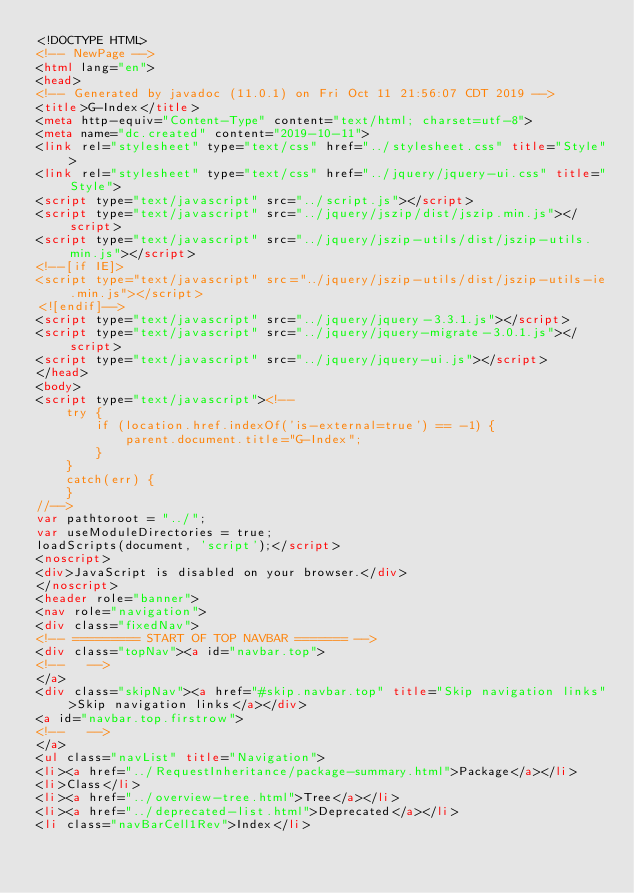<code> <loc_0><loc_0><loc_500><loc_500><_HTML_><!DOCTYPE HTML>
<!-- NewPage -->
<html lang="en">
<head>
<!-- Generated by javadoc (11.0.1) on Fri Oct 11 21:56:07 CDT 2019 -->
<title>G-Index</title>
<meta http-equiv="Content-Type" content="text/html; charset=utf-8">
<meta name="dc.created" content="2019-10-11">
<link rel="stylesheet" type="text/css" href="../stylesheet.css" title="Style">
<link rel="stylesheet" type="text/css" href="../jquery/jquery-ui.css" title="Style">
<script type="text/javascript" src="../script.js"></script>
<script type="text/javascript" src="../jquery/jszip/dist/jszip.min.js"></script>
<script type="text/javascript" src="../jquery/jszip-utils/dist/jszip-utils.min.js"></script>
<!--[if IE]>
<script type="text/javascript" src="../jquery/jszip-utils/dist/jszip-utils-ie.min.js"></script>
<![endif]-->
<script type="text/javascript" src="../jquery/jquery-3.3.1.js"></script>
<script type="text/javascript" src="../jquery/jquery-migrate-3.0.1.js"></script>
<script type="text/javascript" src="../jquery/jquery-ui.js"></script>
</head>
<body>
<script type="text/javascript"><!--
    try {
        if (location.href.indexOf('is-external=true') == -1) {
            parent.document.title="G-Index";
        }
    }
    catch(err) {
    }
//-->
var pathtoroot = "../";
var useModuleDirectories = true;
loadScripts(document, 'script');</script>
<noscript>
<div>JavaScript is disabled on your browser.</div>
</noscript>
<header role="banner">
<nav role="navigation">
<div class="fixedNav">
<!-- ========= START OF TOP NAVBAR ======= -->
<div class="topNav"><a id="navbar.top">
<!--   -->
</a>
<div class="skipNav"><a href="#skip.navbar.top" title="Skip navigation links">Skip navigation links</a></div>
<a id="navbar.top.firstrow">
<!--   -->
</a>
<ul class="navList" title="Navigation">
<li><a href="../RequestInheritance/package-summary.html">Package</a></li>
<li>Class</li>
<li><a href="../overview-tree.html">Tree</a></li>
<li><a href="../deprecated-list.html">Deprecated</a></li>
<li class="navBarCell1Rev">Index</li></code> 